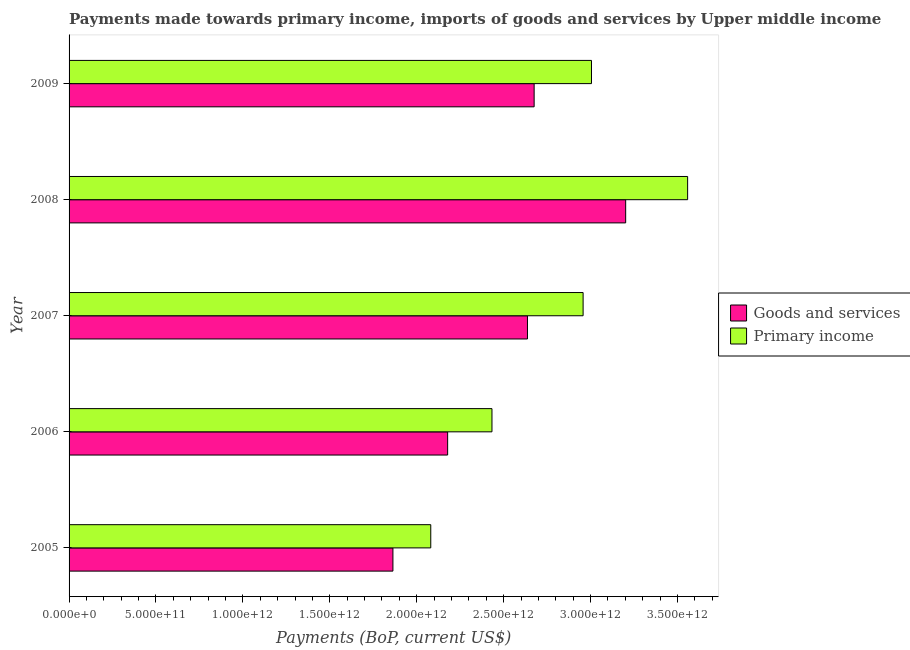How many different coloured bars are there?
Make the answer very short. 2. Are the number of bars on each tick of the Y-axis equal?
Offer a terse response. Yes. In how many cases, is the number of bars for a given year not equal to the number of legend labels?
Ensure brevity in your answer.  0. What is the payments made towards goods and services in 2006?
Offer a very short reply. 2.18e+12. Across all years, what is the maximum payments made towards primary income?
Offer a terse response. 3.56e+12. Across all years, what is the minimum payments made towards primary income?
Your answer should be very brief. 2.08e+12. What is the total payments made towards primary income in the graph?
Provide a succinct answer. 1.40e+13. What is the difference between the payments made towards goods and services in 2006 and that in 2009?
Give a very brief answer. -4.98e+11. What is the difference between the payments made towards goods and services in 2008 and the payments made towards primary income in 2007?
Your answer should be compact. 2.45e+11. What is the average payments made towards primary income per year?
Make the answer very short. 2.81e+12. In the year 2005, what is the difference between the payments made towards primary income and payments made towards goods and services?
Give a very brief answer. 2.18e+11. In how many years, is the payments made towards goods and services greater than 3200000000000 US$?
Ensure brevity in your answer.  1. What is the ratio of the payments made towards primary income in 2005 to that in 2008?
Your response must be concise. 0.58. What is the difference between the highest and the second highest payments made towards goods and services?
Offer a very short reply. 5.27e+11. What is the difference between the highest and the lowest payments made towards primary income?
Provide a succinct answer. 1.48e+12. In how many years, is the payments made towards goods and services greater than the average payments made towards goods and services taken over all years?
Make the answer very short. 3. Is the sum of the payments made towards primary income in 2007 and 2008 greater than the maximum payments made towards goods and services across all years?
Offer a very short reply. Yes. What does the 2nd bar from the top in 2008 represents?
Your answer should be compact. Goods and services. What does the 1st bar from the bottom in 2005 represents?
Offer a very short reply. Goods and services. How many bars are there?
Offer a terse response. 10. How many years are there in the graph?
Your answer should be compact. 5. What is the difference between two consecutive major ticks on the X-axis?
Make the answer very short. 5.00e+11. Are the values on the major ticks of X-axis written in scientific E-notation?
Your response must be concise. Yes. Does the graph contain grids?
Keep it short and to the point. No. Where does the legend appear in the graph?
Provide a short and direct response. Center right. What is the title of the graph?
Ensure brevity in your answer.  Payments made towards primary income, imports of goods and services by Upper middle income. What is the label or title of the X-axis?
Your answer should be very brief. Payments (BoP, current US$). What is the Payments (BoP, current US$) of Goods and services in 2005?
Offer a very short reply. 1.86e+12. What is the Payments (BoP, current US$) of Primary income in 2005?
Ensure brevity in your answer.  2.08e+12. What is the Payments (BoP, current US$) of Goods and services in 2006?
Provide a succinct answer. 2.18e+12. What is the Payments (BoP, current US$) of Primary income in 2006?
Offer a very short reply. 2.43e+12. What is the Payments (BoP, current US$) in Goods and services in 2007?
Keep it short and to the point. 2.64e+12. What is the Payments (BoP, current US$) in Primary income in 2007?
Keep it short and to the point. 2.96e+12. What is the Payments (BoP, current US$) in Goods and services in 2008?
Offer a very short reply. 3.20e+12. What is the Payments (BoP, current US$) in Primary income in 2008?
Offer a terse response. 3.56e+12. What is the Payments (BoP, current US$) of Goods and services in 2009?
Keep it short and to the point. 2.68e+12. What is the Payments (BoP, current US$) in Primary income in 2009?
Provide a short and direct response. 3.01e+12. Across all years, what is the maximum Payments (BoP, current US$) of Goods and services?
Your answer should be compact. 3.20e+12. Across all years, what is the maximum Payments (BoP, current US$) of Primary income?
Offer a terse response. 3.56e+12. Across all years, what is the minimum Payments (BoP, current US$) in Goods and services?
Offer a terse response. 1.86e+12. Across all years, what is the minimum Payments (BoP, current US$) in Primary income?
Offer a very short reply. 2.08e+12. What is the total Payments (BoP, current US$) in Goods and services in the graph?
Ensure brevity in your answer.  1.26e+13. What is the total Payments (BoP, current US$) in Primary income in the graph?
Give a very brief answer. 1.40e+13. What is the difference between the Payments (BoP, current US$) in Goods and services in 2005 and that in 2006?
Provide a succinct answer. -3.15e+11. What is the difference between the Payments (BoP, current US$) in Primary income in 2005 and that in 2006?
Offer a terse response. -3.52e+11. What is the difference between the Payments (BoP, current US$) in Goods and services in 2005 and that in 2007?
Offer a terse response. -7.74e+11. What is the difference between the Payments (BoP, current US$) of Primary income in 2005 and that in 2007?
Make the answer very short. -8.76e+11. What is the difference between the Payments (BoP, current US$) of Goods and services in 2005 and that in 2008?
Make the answer very short. -1.34e+12. What is the difference between the Payments (BoP, current US$) in Primary income in 2005 and that in 2008?
Provide a short and direct response. -1.48e+12. What is the difference between the Payments (BoP, current US$) in Goods and services in 2005 and that in 2009?
Give a very brief answer. -8.12e+11. What is the difference between the Payments (BoP, current US$) of Primary income in 2005 and that in 2009?
Provide a short and direct response. -9.25e+11. What is the difference between the Payments (BoP, current US$) in Goods and services in 2006 and that in 2007?
Your answer should be compact. -4.59e+11. What is the difference between the Payments (BoP, current US$) of Primary income in 2006 and that in 2007?
Make the answer very short. -5.24e+11. What is the difference between the Payments (BoP, current US$) in Goods and services in 2006 and that in 2008?
Offer a very short reply. -1.02e+12. What is the difference between the Payments (BoP, current US$) in Primary income in 2006 and that in 2008?
Keep it short and to the point. -1.13e+12. What is the difference between the Payments (BoP, current US$) of Goods and services in 2006 and that in 2009?
Provide a short and direct response. -4.98e+11. What is the difference between the Payments (BoP, current US$) in Primary income in 2006 and that in 2009?
Your answer should be very brief. -5.72e+11. What is the difference between the Payments (BoP, current US$) in Goods and services in 2007 and that in 2008?
Provide a succinct answer. -5.65e+11. What is the difference between the Payments (BoP, current US$) of Primary income in 2007 and that in 2008?
Make the answer very short. -6.01e+11. What is the difference between the Payments (BoP, current US$) of Goods and services in 2007 and that in 2009?
Your response must be concise. -3.83e+1. What is the difference between the Payments (BoP, current US$) in Primary income in 2007 and that in 2009?
Keep it short and to the point. -4.81e+1. What is the difference between the Payments (BoP, current US$) of Goods and services in 2008 and that in 2009?
Your answer should be very brief. 5.27e+11. What is the difference between the Payments (BoP, current US$) of Primary income in 2008 and that in 2009?
Ensure brevity in your answer.  5.53e+11. What is the difference between the Payments (BoP, current US$) of Goods and services in 2005 and the Payments (BoP, current US$) of Primary income in 2006?
Offer a terse response. -5.70e+11. What is the difference between the Payments (BoP, current US$) of Goods and services in 2005 and the Payments (BoP, current US$) of Primary income in 2007?
Offer a terse response. -1.09e+12. What is the difference between the Payments (BoP, current US$) of Goods and services in 2005 and the Payments (BoP, current US$) of Primary income in 2008?
Offer a very short reply. -1.70e+12. What is the difference between the Payments (BoP, current US$) of Goods and services in 2005 and the Payments (BoP, current US$) of Primary income in 2009?
Provide a short and direct response. -1.14e+12. What is the difference between the Payments (BoP, current US$) in Goods and services in 2006 and the Payments (BoP, current US$) in Primary income in 2007?
Make the answer very short. -7.79e+11. What is the difference between the Payments (BoP, current US$) of Goods and services in 2006 and the Payments (BoP, current US$) of Primary income in 2008?
Ensure brevity in your answer.  -1.38e+12. What is the difference between the Payments (BoP, current US$) in Goods and services in 2006 and the Payments (BoP, current US$) in Primary income in 2009?
Your response must be concise. -8.27e+11. What is the difference between the Payments (BoP, current US$) of Goods and services in 2007 and the Payments (BoP, current US$) of Primary income in 2008?
Make the answer very short. -9.21e+11. What is the difference between the Payments (BoP, current US$) of Goods and services in 2007 and the Payments (BoP, current US$) of Primary income in 2009?
Your answer should be very brief. -3.68e+11. What is the difference between the Payments (BoP, current US$) of Goods and services in 2008 and the Payments (BoP, current US$) of Primary income in 2009?
Your answer should be compact. 1.97e+11. What is the average Payments (BoP, current US$) of Goods and services per year?
Ensure brevity in your answer.  2.51e+12. What is the average Payments (BoP, current US$) of Primary income per year?
Make the answer very short. 2.81e+12. In the year 2005, what is the difference between the Payments (BoP, current US$) in Goods and services and Payments (BoP, current US$) in Primary income?
Your response must be concise. -2.18e+11. In the year 2006, what is the difference between the Payments (BoP, current US$) in Goods and services and Payments (BoP, current US$) in Primary income?
Keep it short and to the point. -2.55e+11. In the year 2007, what is the difference between the Payments (BoP, current US$) in Goods and services and Payments (BoP, current US$) in Primary income?
Your answer should be compact. -3.20e+11. In the year 2008, what is the difference between the Payments (BoP, current US$) of Goods and services and Payments (BoP, current US$) of Primary income?
Make the answer very short. -3.56e+11. In the year 2009, what is the difference between the Payments (BoP, current US$) in Goods and services and Payments (BoP, current US$) in Primary income?
Keep it short and to the point. -3.30e+11. What is the ratio of the Payments (BoP, current US$) of Goods and services in 2005 to that in 2006?
Provide a short and direct response. 0.86. What is the ratio of the Payments (BoP, current US$) of Primary income in 2005 to that in 2006?
Your answer should be compact. 0.86. What is the ratio of the Payments (BoP, current US$) in Goods and services in 2005 to that in 2007?
Provide a succinct answer. 0.71. What is the ratio of the Payments (BoP, current US$) of Primary income in 2005 to that in 2007?
Your answer should be compact. 0.7. What is the ratio of the Payments (BoP, current US$) in Goods and services in 2005 to that in 2008?
Offer a terse response. 0.58. What is the ratio of the Payments (BoP, current US$) in Primary income in 2005 to that in 2008?
Provide a short and direct response. 0.58. What is the ratio of the Payments (BoP, current US$) in Goods and services in 2005 to that in 2009?
Keep it short and to the point. 0.7. What is the ratio of the Payments (BoP, current US$) of Primary income in 2005 to that in 2009?
Make the answer very short. 0.69. What is the ratio of the Payments (BoP, current US$) of Goods and services in 2006 to that in 2007?
Offer a very short reply. 0.83. What is the ratio of the Payments (BoP, current US$) of Primary income in 2006 to that in 2007?
Make the answer very short. 0.82. What is the ratio of the Payments (BoP, current US$) of Goods and services in 2006 to that in 2008?
Keep it short and to the point. 0.68. What is the ratio of the Payments (BoP, current US$) of Primary income in 2006 to that in 2008?
Provide a succinct answer. 0.68. What is the ratio of the Payments (BoP, current US$) of Goods and services in 2006 to that in 2009?
Offer a very short reply. 0.81. What is the ratio of the Payments (BoP, current US$) in Primary income in 2006 to that in 2009?
Provide a succinct answer. 0.81. What is the ratio of the Payments (BoP, current US$) of Goods and services in 2007 to that in 2008?
Give a very brief answer. 0.82. What is the ratio of the Payments (BoP, current US$) of Primary income in 2007 to that in 2008?
Make the answer very short. 0.83. What is the ratio of the Payments (BoP, current US$) in Goods and services in 2007 to that in 2009?
Keep it short and to the point. 0.99. What is the ratio of the Payments (BoP, current US$) of Primary income in 2007 to that in 2009?
Your answer should be very brief. 0.98. What is the ratio of the Payments (BoP, current US$) in Goods and services in 2008 to that in 2009?
Offer a terse response. 1.2. What is the ratio of the Payments (BoP, current US$) in Primary income in 2008 to that in 2009?
Your answer should be very brief. 1.18. What is the difference between the highest and the second highest Payments (BoP, current US$) in Goods and services?
Provide a succinct answer. 5.27e+11. What is the difference between the highest and the second highest Payments (BoP, current US$) in Primary income?
Give a very brief answer. 5.53e+11. What is the difference between the highest and the lowest Payments (BoP, current US$) in Goods and services?
Keep it short and to the point. 1.34e+12. What is the difference between the highest and the lowest Payments (BoP, current US$) of Primary income?
Ensure brevity in your answer.  1.48e+12. 